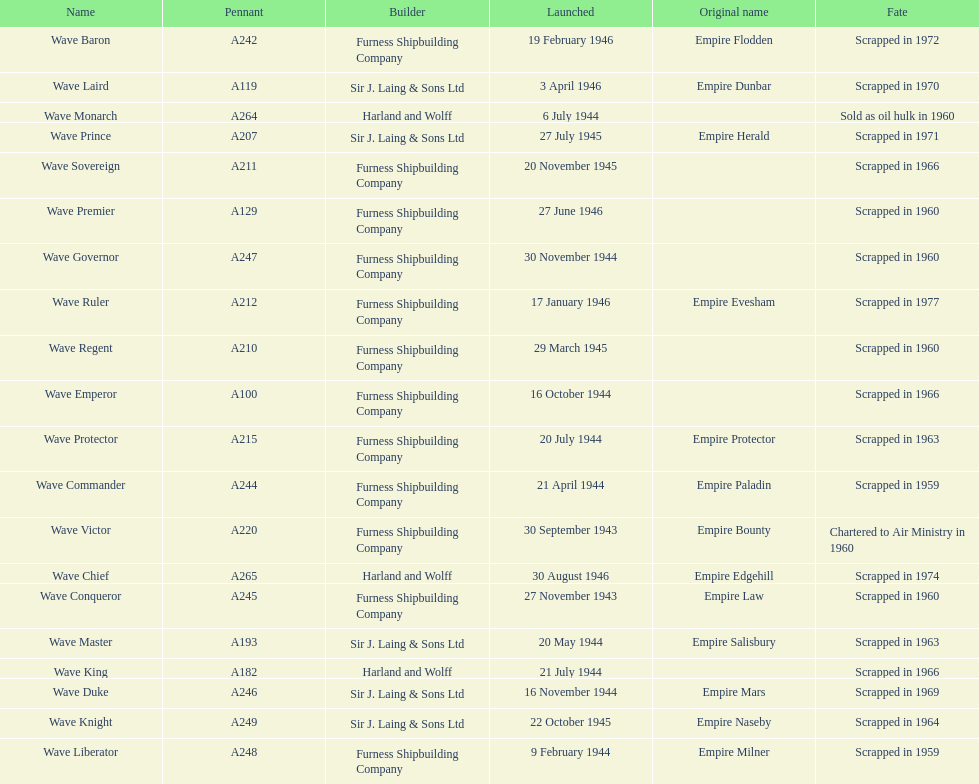How many ships were launched in the year 1944? 9. 